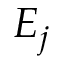Convert formula to latex. <formula><loc_0><loc_0><loc_500><loc_500>E _ { j }</formula> 